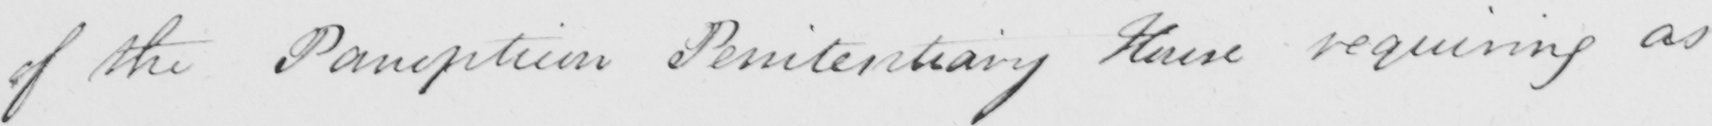Please transcribe the handwritten text in this image. of the Panopticon Penitentiary House requiring as 